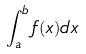<formula> <loc_0><loc_0><loc_500><loc_500>\int _ { a } ^ { b } f ( x ) d x</formula> 